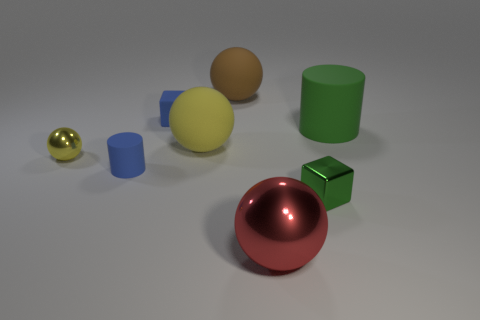Subtract all big balls. How many balls are left? 1 Add 1 green matte things. How many objects exist? 9 Subtract all cubes. How many objects are left? 6 Subtract all brown spheres. How many spheres are left? 3 Add 7 big red metal spheres. How many big red metal spheres exist? 8 Subtract 0 red cubes. How many objects are left? 8 Subtract 2 balls. How many balls are left? 2 Subtract all gray cylinders. Subtract all blue blocks. How many cylinders are left? 2 Subtract all cyan cylinders. How many brown spheres are left? 1 Subtract all small yellow metal spheres. Subtract all brown things. How many objects are left? 6 